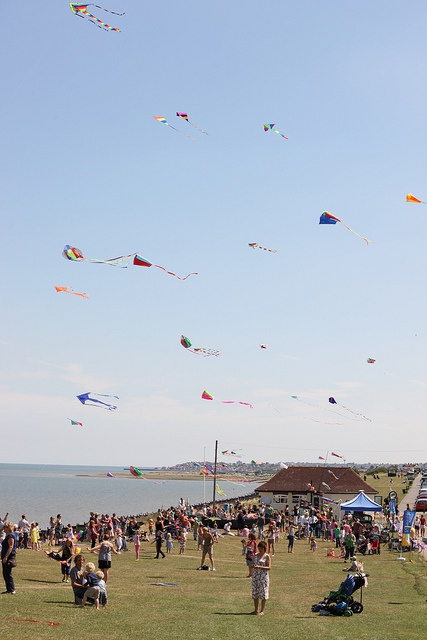Describe the objects in this image and their specific colors. I can see people in darkgray, black, gray, and maroon tones, people in darkgray, black, maroon, and gray tones, people in darkgray, gray, maroon, and black tones, kite in darkgray and lightblue tones, and kite in darkgray, lightblue, and khaki tones in this image. 